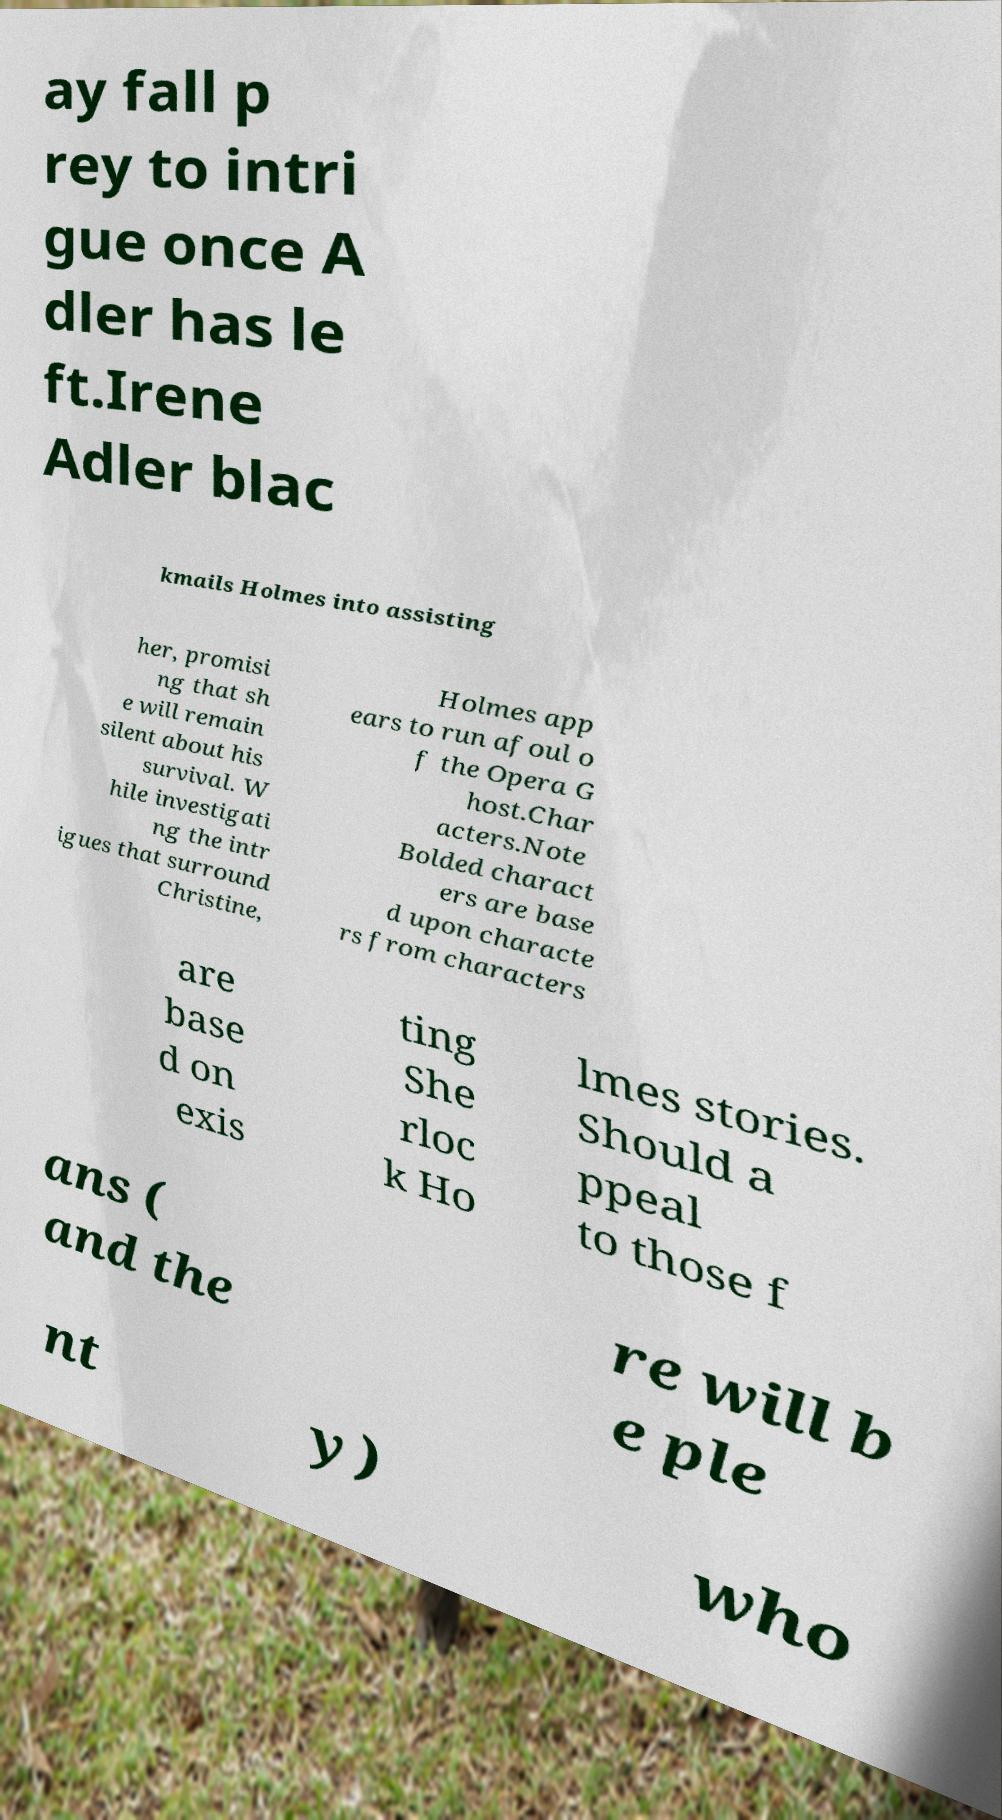I need the written content from this picture converted into text. Can you do that? ay fall p rey to intri gue once A dler has le ft.Irene Adler blac kmails Holmes into assisting her, promisi ng that sh e will remain silent about his survival. W hile investigati ng the intr igues that surround Christine, Holmes app ears to run afoul o f the Opera G host.Char acters.Note Bolded charact ers are base d upon characte rs from characters are base d on exis ting She rloc k Ho lmes stories. Should a ppeal to those f ans ( and the re will b e ple nt y) who 